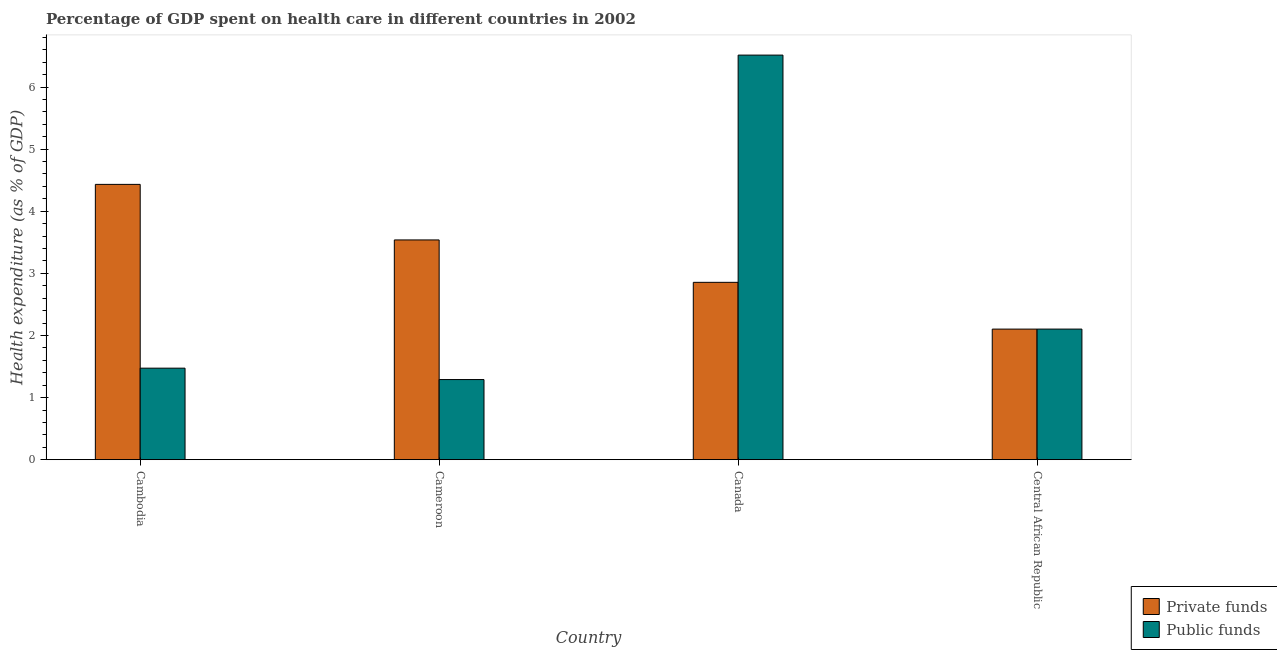Are the number of bars on each tick of the X-axis equal?
Make the answer very short. Yes. How many bars are there on the 4th tick from the left?
Make the answer very short. 2. What is the label of the 4th group of bars from the left?
Make the answer very short. Central African Republic. In how many cases, is the number of bars for a given country not equal to the number of legend labels?
Ensure brevity in your answer.  0. What is the amount of private funds spent in healthcare in Canada?
Provide a succinct answer. 2.86. Across all countries, what is the maximum amount of public funds spent in healthcare?
Ensure brevity in your answer.  6.51. Across all countries, what is the minimum amount of private funds spent in healthcare?
Your answer should be compact. 2.1. In which country was the amount of private funds spent in healthcare maximum?
Keep it short and to the point. Cambodia. In which country was the amount of private funds spent in healthcare minimum?
Ensure brevity in your answer.  Central African Republic. What is the total amount of private funds spent in healthcare in the graph?
Provide a short and direct response. 12.93. What is the difference between the amount of public funds spent in healthcare in Canada and that in Central African Republic?
Your response must be concise. 4.41. What is the difference between the amount of private funds spent in healthcare in Canada and the amount of public funds spent in healthcare in Cameroon?
Your answer should be compact. 1.57. What is the average amount of private funds spent in healthcare per country?
Keep it short and to the point. 3.23. What is the difference between the amount of public funds spent in healthcare and amount of private funds spent in healthcare in Cambodia?
Your answer should be compact. -2.96. In how many countries, is the amount of public funds spent in healthcare greater than 0.4 %?
Your response must be concise. 4. What is the ratio of the amount of public funds spent in healthcare in Cameroon to that in Canada?
Ensure brevity in your answer.  0.2. Is the amount of public funds spent in healthcare in Cambodia less than that in Cameroon?
Make the answer very short. No. What is the difference between the highest and the second highest amount of private funds spent in healthcare?
Give a very brief answer. 0.89. What is the difference between the highest and the lowest amount of private funds spent in healthcare?
Your answer should be very brief. 2.33. In how many countries, is the amount of public funds spent in healthcare greater than the average amount of public funds spent in healthcare taken over all countries?
Make the answer very short. 1. Is the sum of the amount of public funds spent in healthcare in Canada and Central African Republic greater than the maximum amount of private funds spent in healthcare across all countries?
Provide a short and direct response. Yes. What does the 2nd bar from the left in Central African Republic represents?
Provide a short and direct response. Public funds. What does the 2nd bar from the right in Central African Republic represents?
Your response must be concise. Private funds. How many bars are there?
Your answer should be compact. 8. How many countries are there in the graph?
Your answer should be compact. 4. Are the values on the major ticks of Y-axis written in scientific E-notation?
Provide a succinct answer. No. Does the graph contain any zero values?
Offer a terse response. No. Does the graph contain grids?
Your response must be concise. No. How many legend labels are there?
Offer a very short reply. 2. What is the title of the graph?
Provide a short and direct response. Percentage of GDP spent on health care in different countries in 2002. What is the label or title of the X-axis?
Give a very brief answer. Country. What is the label or title of the Y-axis?
Offer a terse response. Health expenditure (as % of GDP). What is the Health expenditure (as % of GDP) in Private funds in Cambodia?
Provide a succinct answer. 4.43. What is the Health expenditure (as % of GDP) in Public funds in Cambodia?
Provide a short and direct response. 1.47. What is the Health expenditure (as % of GDP) in Private funds in Cameroon?
Your answer should be compact. 3.54. What is the Health expenditure (as % of GDP) of Public funds in Cameroon?
Ensure brevity in your answer.  1.29. What is the Health expenditure (as % of GDP) in Private funds in Canada?
Your answer should be compact. 2.86. What is the Health expenditure (as % of GDP) of Public funds in Canada?
Offer a terse response. 6.51. What is the Health expenditure (as % of GDP) of Private funds in Central African Republic?
Provide a succinct answer. 2.1. What is the Health expenditure (as % of GDP) of Public funds in Central African Republic?
Ensure brevity in your answer.  2.1. Across all countries, what is the maximum Health expenditure (as % of GDP) in Private funds?
Provide a short and direct response. 4.43. Across all countries, what is the maximum Health expenditure (as % of GDP) in Public funds?
Your answer should be compact. 6.51. Across all countries, what is the minimum Health expenditure (as % of GDP) of Private funds?
Give a very brief answer. 2.1. Across all countries, what is the minimum Health expenditure (as % of GDP) in Public funds?
Offer a terse response. 1.29. What is the total Health expenditure (as % of GDP) in Private funds in the graph?
Keep it short and to the point. 12.93. What is the total Health expenditure (as % of GDP) in Public funds in the graph?
Your response must be concise. 11.38. What is the difference between the Health expenditure (as % of GDP) of Private funds in Cambodia and that in Cameroon?
Your answer should be compact. 0.89. What is the difference between the Health expenditure (as % of GDP) in Public funds in Cambodia and that in Cameroon?
Your answer should be compact. 0.18. What is the difference between the Health expenditure (as % of GDP) of Private funds in Cambodia and that in Canada?
Your answer should be compact. 1.58. What is the difference between the Health expenditure (as % of GDP) in Public funds in Cambodia and that in Canada?
Offer a very short reply. -5.04. What is the difference between the Health expenditure (as % of GDP) of Private funds in Cambodia and that in Central African Republic?
Offer a terse response. 2.33. What is the difference between the Health expenditure (as % of GDP) of Public funds in Cambodia and that in Central African Republic?
Give a very brief answer. -0.63. What is the difference between the Health expenditure (as % of GDP) of Private funds in Cameroon and that in Canada?
Your response must be concise. 0.68. What is the difference between the Health expenditure (as % of GDP) in Public funds in Cameroon and that in Canada?
Keep it short and to the point. -5.22. What is the difference between the Health expenditure (as % of GDP) of Private funds in Cameroon and that in Central African Republic?
Provide a succinct answer. 1.44. What is the difference between the Health expenditure (as % of GDP) of Public funds in Cameroon and that in Central African Republic?
Give a very brief answer. -0.81. What is the difference between the Health expenditure (as % of GDP) in Private funds in Canada and that in Central African Republic?
Offer a very short reply. 0.75. What is the difference between the Health expenditure (as % of GDP) in Public funds in Canada and that in Central African Republic?
Your answer should be compact. 4.41. What is the difference between the Health expenditure (as % of GDP) in Private funds in Cambodia and the Health expenditure (as % of GDP) in Public funds in Cameroon?
Make the answer very short. 3.14. What is the difference between the Health expenditure (as % of GDP) in Private funds in Cambodia and the Health expenditure (as % of GDP) in Public funds in Canada?
Provide a succinct answer. -2.08. What is the difference between the Health expenditure (as % of GDP) of Private funds in Cambodia and the Health expenditure (as % of GDP) of Public funds in Central African Republic?
Keep it short and to the point. 2.33. What is the difference between the Health expenditure (as % of GDP) in Private funds in Cameroon and the Health expenditure (as % of GDP) in Public funds in Canada?
Your answer should be very brief. -2.98. What is the difference between the Health expenditure (as % of GDP) in Private funds in Cameroon and the Health expenditure (as % of GDP) in Public funds in Central African Republic?
Your answer should be compact. 1.44. What is the difference between the Health expenditure (as % of GDP) of Private funds in Canada and the Health expenditure (as % of GDP) of Public funds in Central African Republic?
Your answer should be compact. 0.75. What is the average Health expenditure (as % of GDP) of Private funds per country?
Offer a terse response. 3.23. What is the average Health expenditure (as % of GDP) in Public funds per country?
Your answer should be compact. 2.85. What is the difference between the Health expenditure (as % of GDP) in Private funds and Health expenditure (as % of GDP) in Public funds in Cambodia?
Give a very brief answer. 2.96. What is the difference between the Health expenditure (as % of GDP) in Private funds and Health expenditure (as % of GDP) in Public funds in Cameroon?
Provide a succinct answer. 2.25. What is the difference between the Health expenditure (as % of GDP) of Private funds and Health expenditure (as % of GDP) of Public funds in Canada?
Provide a short and direct response. -3.66. What is the difference between the Health expenditure (as % of GDP) of Private funds and Health expenditure (as % of GDP) of Public funds in Central African Republic?
Your response must be concise. -0. What is the ratio of the Health expenditure (as % of GDP) of Private funds in Cambodia to that in Cameroon?
Offer a very short reply. 1.25. What is the ratio of the Health expenditure (as % of GDP) in Public funds in Cambodia to that in Cameroon?
Provide a short and direct response. 1.14. What is the ratio of the Health expenditure (as % of GDP) in Private funds in Cambodia to that in Canada?
Give a very brief answer. 1.55. What is the ratio of the Health expenditure (as % of GDP) in Public funds in Cambodia to that in Canada?
Offer a terse response. 0.23. What is the ratio of the Health expenditure (as % of GDP) of Private funds in Cambodia to that in Central African Republic?
Provide a short and direct response. 2.11. What is the ratio of the Health expenditure (as % of GDP) in Public funds in Cambodia to that in Central African Republic?
Offer a very short reply. 0.7. What is the ratio of the Health expenditure (as % of GDP) in Private funds in Cameroon to that in Canada?
Make the answer very short. 1.24. What is the ratio of the Health expenditure (as % of GDP) in Public funds in Cameroon to that in Canada?
Ensure brevity in your answer.  0.2. What is the ratio of the Health expenditure (as % of GDP) of Private funds in Cameroon to that in Central African Republic?
Offer a terse response. 1.68. What is the ratio of the Health expenditure (as % of GDP) in Public funds in Cameroon to that in Central African Republic?
Keep it short and to the point. 0.61. What is the ratio of the Health expenditure (as % of GDP) in Private funds in Canada to that in Central African Republic?
Your answer should be very brief. 1.36. What is the ratio of the Health expenditure (as % of GDP) in Public funds in Canada to that in Central African Republic?
Keep it short and to the point. 3.1. What is the difference between the highest and the second highest Health expenditure (as % of GDP) in Private funds?
Make the answer very short. 0.89. What is the difference between the highest and the second highest Health expenditure (as % of GDP) of Public funds?
Your answer should be very brief. 4.41. What is the difference between the highest and the lowest Health expenditure (as % of GDP) in Private funds?
Give a very brief answer. 2.33. What is the difference between the highest and the lowest Health expenditure (as % of GDP) in Public funds?
Provide a succinct answer. 5.22. 